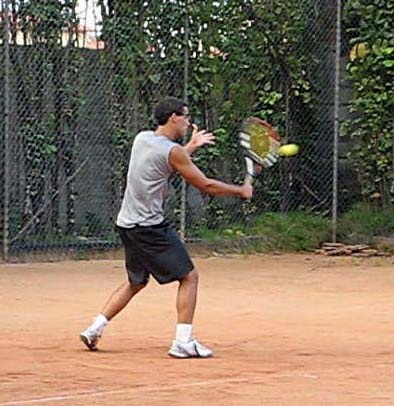Describe the objects in this image and their specific colors. I can see people in lavender, black, lightgray, darkgray, and salmon tones, tennis racket in lavender, gray, olive, and darkgray tones, and sports ball in lavender, olive, and khaki tones in this image. 